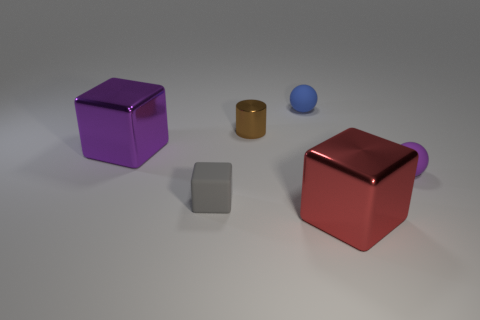What could be the use of the red object with a handle? The red object with a handle resembles a container or a jar. It's possible that the handle is designed for easy gripping, suggesting the object could be used for storage and is likely to be opened frequently. Is there any indication of what might be inside it? There are no visible clues in the image regarding the contents of the red container, as it is closed. Its purpose and what it holds remain speculative without more context. 